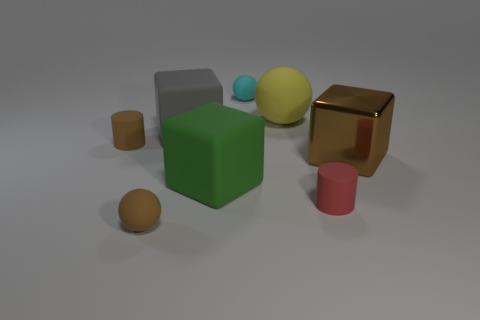Could you describe the shapes and colors of the objects in the image? Certainly! The image displays a variety of geometric shapes: there is a large green cube, a smaller brown cube with a reflective surface, a gray cuboid, a pink cylinder, a blue sphere, and two more spheres, one orange and one yellow. The assortment of shapes and colors creates a visually interesting composition, perhaps indicative of a study in three-dimensional modeling or an exercise in color and shape recognition. 